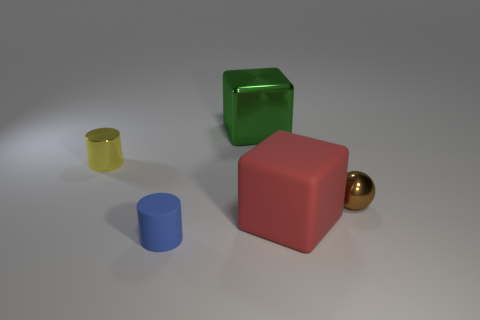Add 2 small cyan metal cylinders. How many objects exist? 7 Subtract all cylinders. How many objects are left? 3 Add 2 large red blocks. How many large red blocks are left? 3 Add 2 yellow metallic things. How many yellow metallic things exist? 3 Subtract 1 green blocks. How many objects are left? 4 Subtract all purple metallic balls. Subtract all tiny yellow shiny cylinders. How many objects are left? 4 